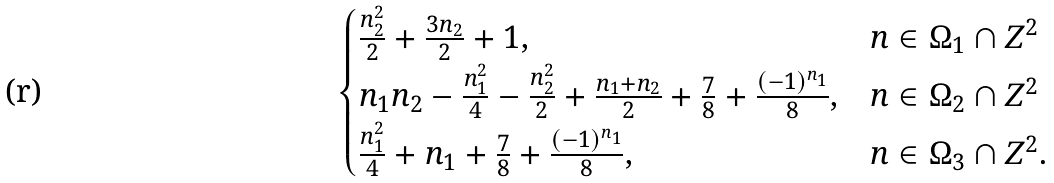Convert formula to latex. <formula><loc_0><loc_0><loc_500><loc_500>\begin{cases} \frac { n _ { 2 } ^ { 2 } } { 2 } + \frac { 3 n _ { 2 } } { 2 } + 1 , & { n } \in \Omega _ { 1 } \cap { Z } ^ { 2 } \\ n _ { 1 } n _ { 2 } - \frac { n _ { 1 } ^ { 2 } } { 4 } - \frac { n _ { 2 } ^ { 2 } } { 2 } + \frac { n _ { 1 } + n _ { 2 } } { 2 } + \frac { 7 } { 8 } + \frac { ( - 1 ) ^ { n _ { 1 } } } { 8 } , & { n } \in \Omega _ { 2 } \cap { Z } ^ { 2 } \\ \frac { n _ { 1 } ^ { 2 } } { 4 } + n _ { 1 } + \frac { 7 } { 8 } + \frac { ( - 1 ) ^ { n _ { 1 } } } { 8 } , & { n } \in \Omega _ { 3 } \cap { Z } ^ { 2 } . \end{cases}</formula> 